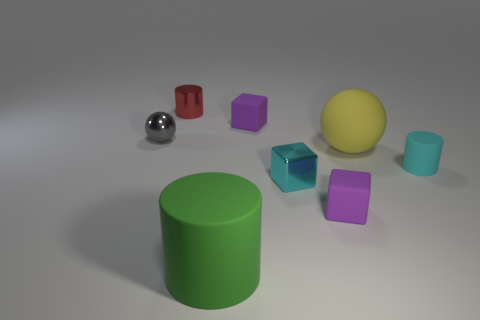Subtract all cyan spheres. Subtract all red cylinders. How many spheres are left? 2 Add 2 cylinders. How many objects exist? 10 Subtract all balls. How many objects are left? 6 Add 5 tiny cubes. How many tiny cubes exist? 8 Subtract 0 gray blocks. How many objects are left? 8 Subtract all cyan blocks. Subtract all gray spheres. How many objects are left? 6 Add 5 small cyan rubber things. How many small cyan rubber things are left? 6 